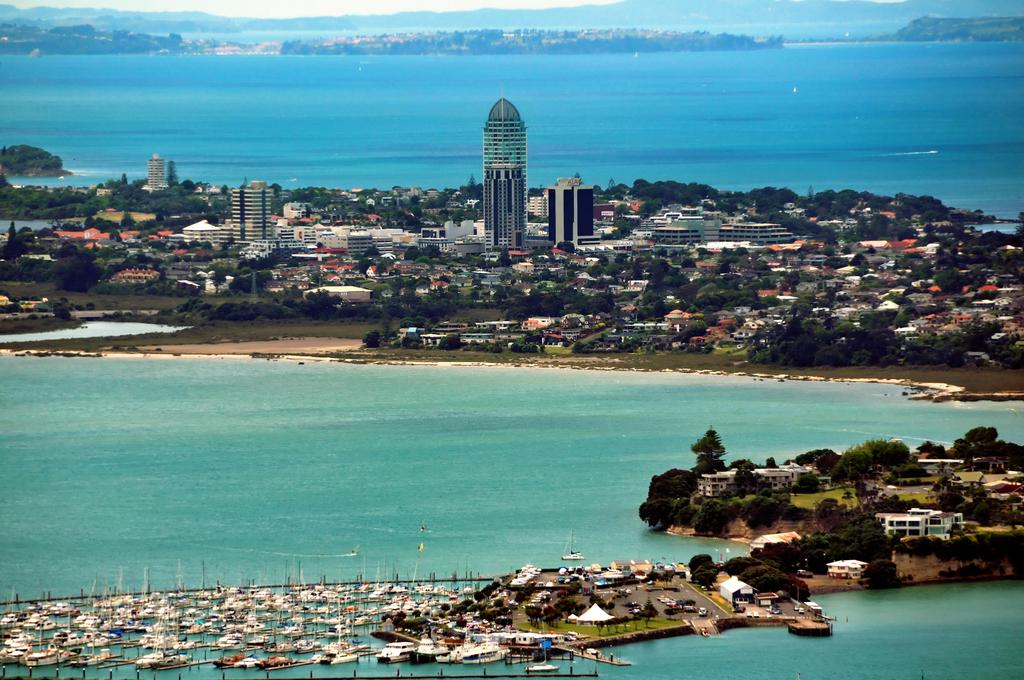What is the primary element in the image? There is water in the image. What is floating on the surface of the water? There are boats on the surface of the water. What can be seen below the water level? The ground is visible in the image. What type of vegetation is present in the image? There are trees in the image. What type of man-made structures are visible in the image? There are buildings in the image. What is visible in the background of the image? In the background, there is water, mountains, and the sky visible. What type of watch is the boat wearing in the image? There are no watches present in the image, as boats do not wear watches. What type of linen is draped over the mountains in the background? There is no linen draped over the mountains in the background, as the image only shows natural elements such as water, trees, and mountains. 